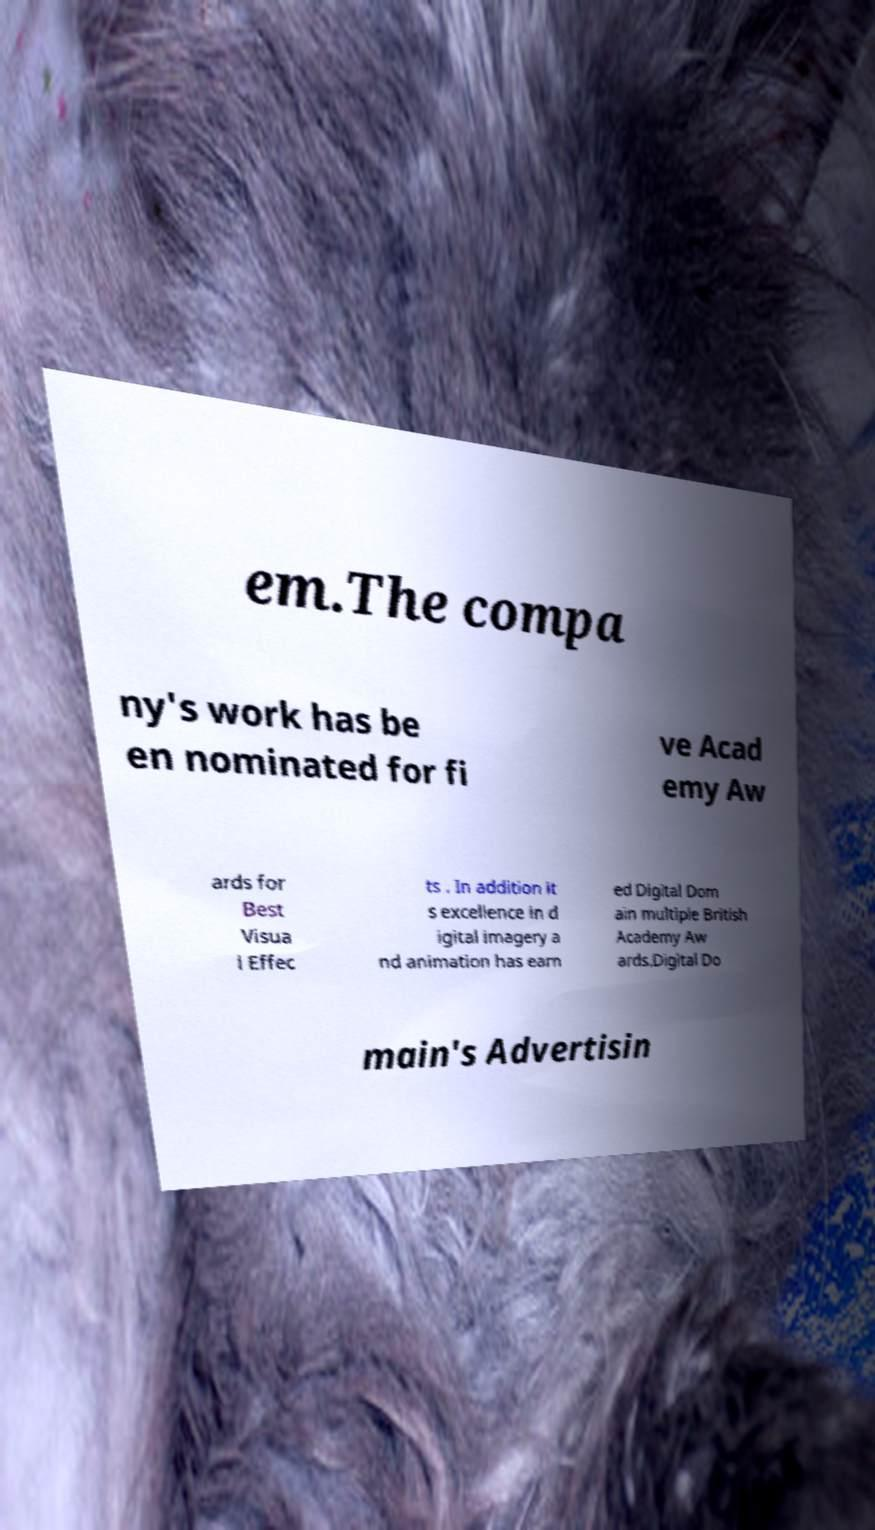Please read and relay the text visible in this image. What does it say? em.The compa ny's work has be en nominated for fi ve Acad emy Aw ards for Best Visua l Effec ts . In addition it s excellence in d igital imagery a nd animation has earn ed Digital Dom ain multiple British Academy Aw ards.Digital Do main's Advertisin 